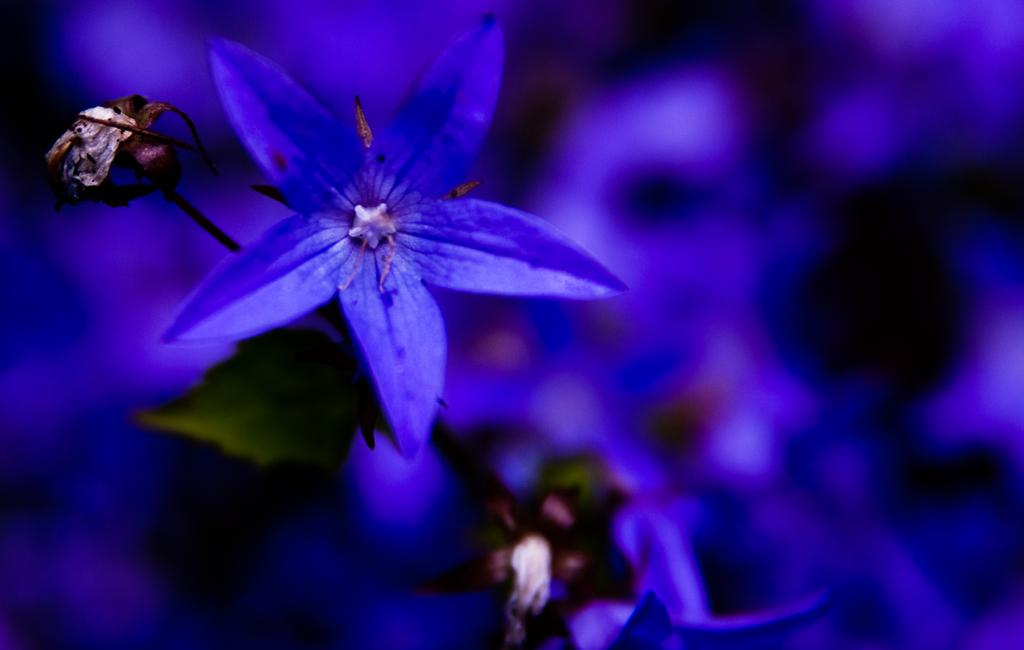What type of plants can be seen in the image? There are flowers in the image. What part of the flowers is visible in the image? There are stems in the image. What type of circle can be seen in the image? There is no circle present in the image. Is there a rainstorm happening in the image? There is no indication of a rainstorm in the image. 